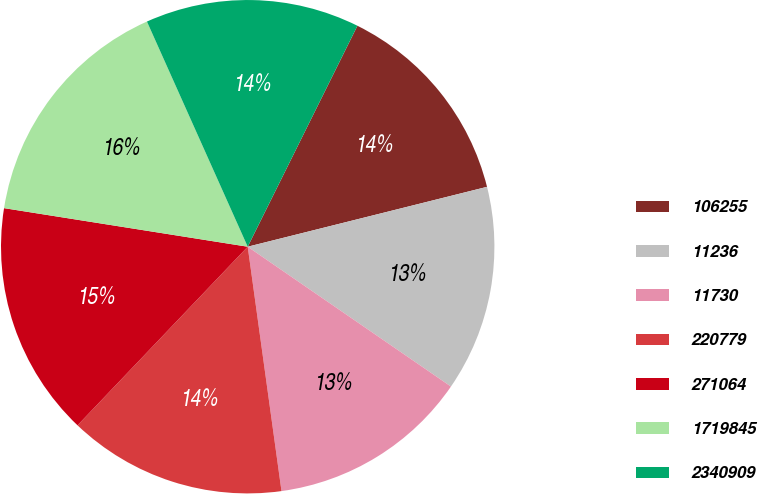Convert chart. <chart><loc_0><loc_0><loc_500><loc_500><pie_chart><fcel>106255<fcel>11236<fcel>11730<fcel>220779<fcel>271064<fcel>1719845<fcel>2340909<nl><fcel>13.76%<fcel>13.49%<fcel>13.22%<fcel>14.3%<fcel>15.38%<fcel>15.8%<fcel>14.03%<nl></chart> 